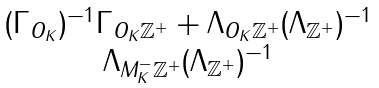Convert formula to latex. <formula><loc_0><loc_0><loc_500><loc_500>\begin{matrix} ( \Gamma _ { O _ { K } } ) ^ { - 1 } \Gamma _ { O _ { K } \mathbb { Z } ^ { + } } + \Lambda _ { O _ { K } \mathbb { Z } ^ { + } } ( \Lambda _ { \mathbb { Z } ^ { + } } ) ^ { - 1 } \\ \Lambda _ { M _ { K } ^ { - } \mathbb { Z } ^ { + } } ( \Lambda _ { \mathbb { Z } ^ { + } } ) ^ { - 1 } \end{matrix}</formula> 